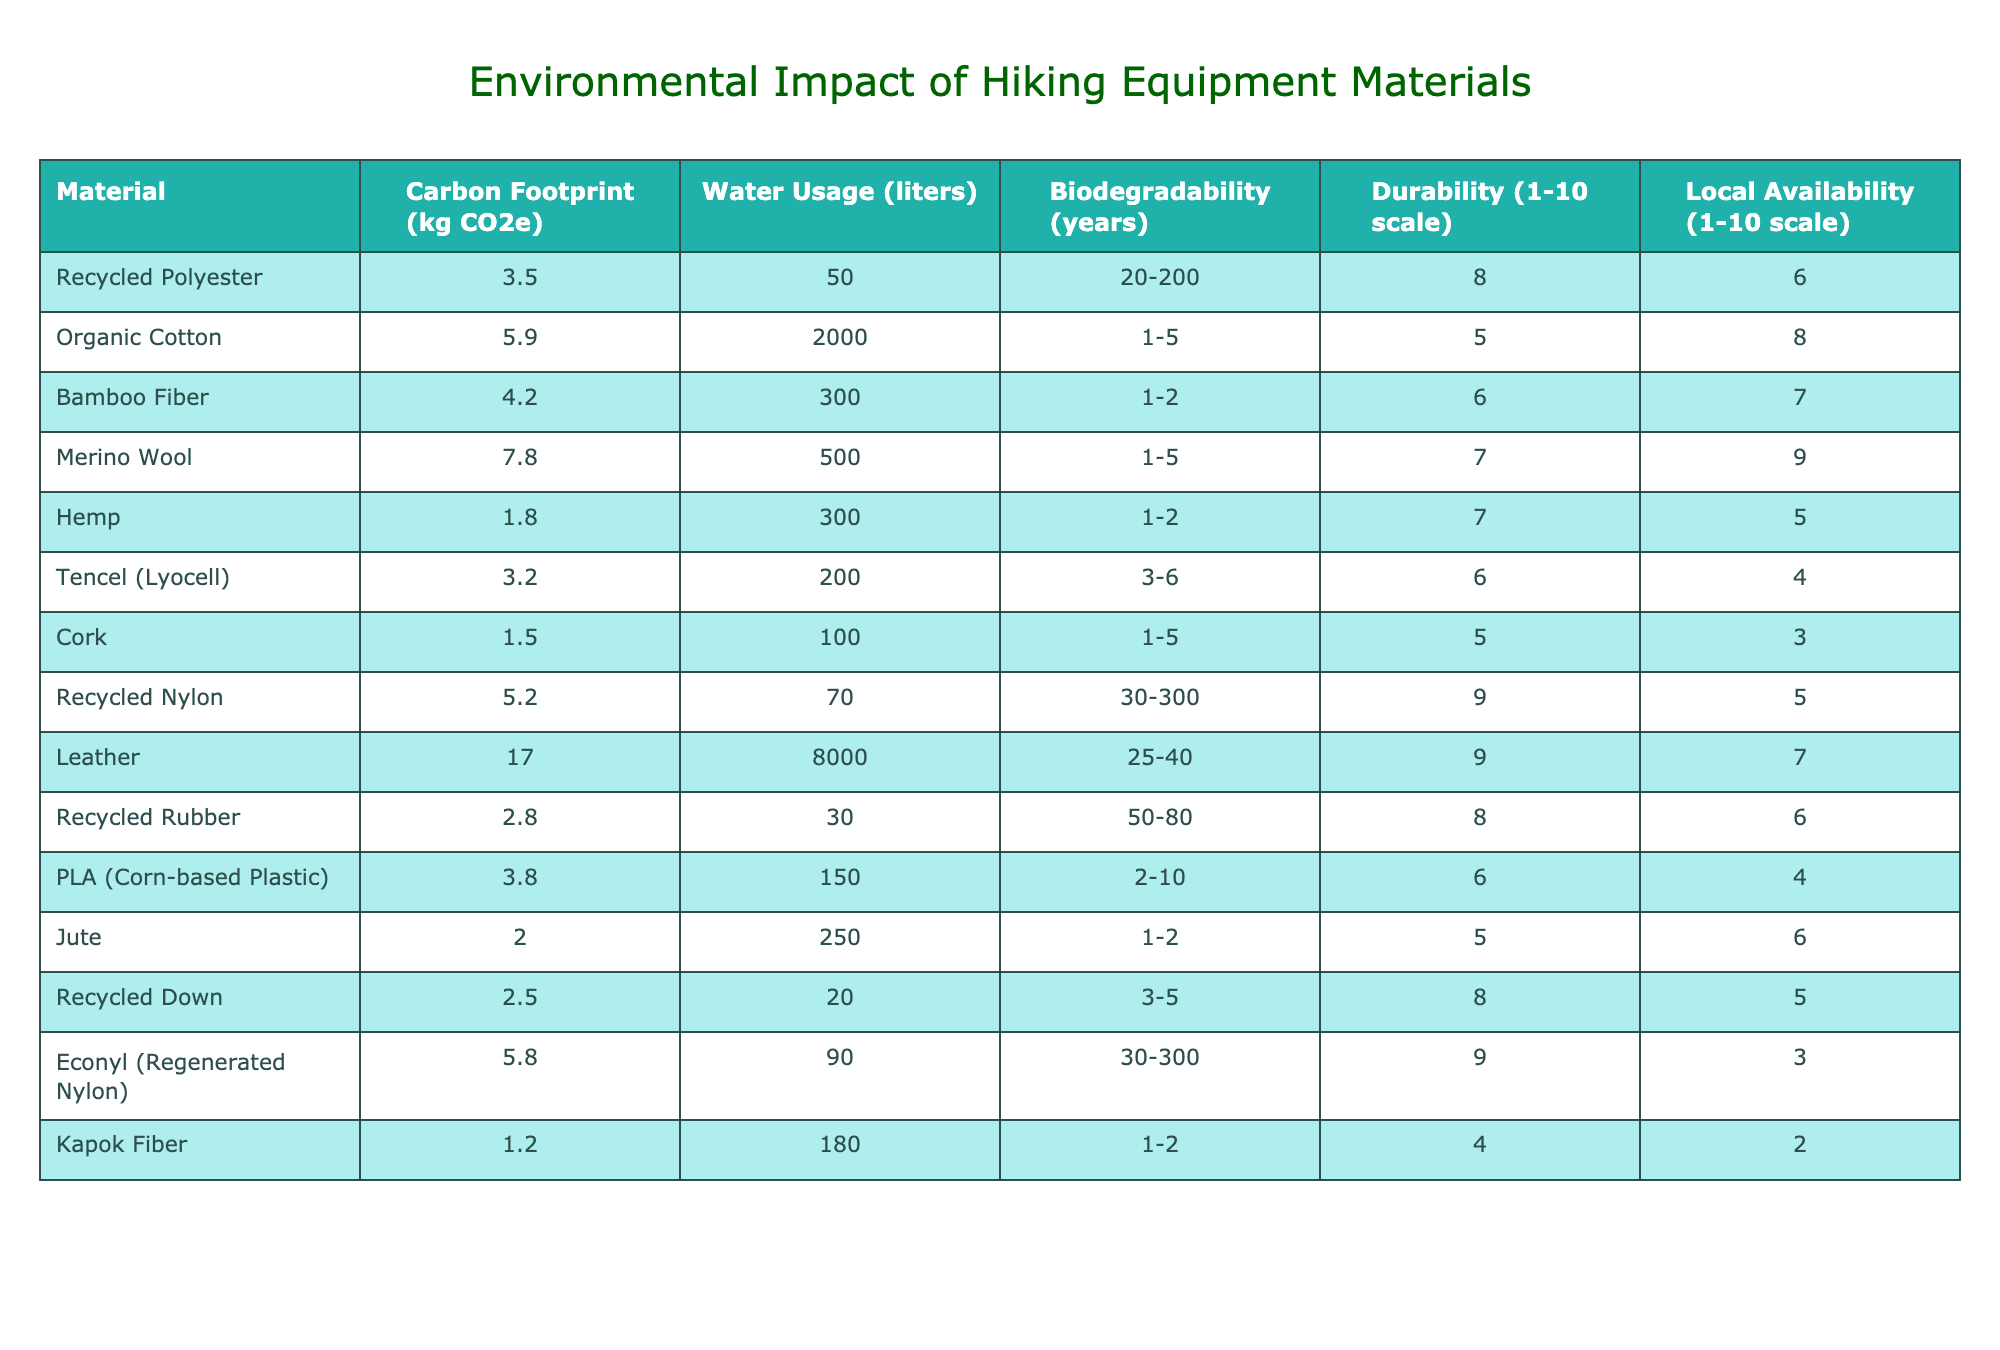What material has the lowest carbon footprint? The carbon footprints of the materials are listed in the second column. When comparing the values, Cork has the lowest footprint at 1.5 kg CO2e.
Answer: 1.5 kg CO2e How many liters of water does Organic Cotton use compared to Hemp? The water usage for Organic Cotton is 2000 liters and for Hemp, it is 300 liters. The difference is 2000 - 300 = 1700 liters more for Organic Cotton.
Answer: 1700 liters Is Merino Wool biodegradable in 30 years? Merino Wool has a biodegradability range of 1-5 years, which means it cannot be biodegradable in 30 years.
Answer: No What is the average carbon footprint of the biodegradable materials? The biodegradable materials are Organic Cotton, Bamboo Fiber, Hemp, Merino Wool, Jute, and Kapok Fiber. Their carbon footprints are 5.9, 4.2, 1.8, 7.8, 2.0, and 1.2 kg CO2e respectively. Summing these gives 23.9 kg CO2e, dividing by 6 gives the average of approximately 3.98 kg CO2e.
Answer: 3.98 kg CO2e Which material has the highest durability rating? The durability ratings are provided on a scale of 1-10, with the highest being Leather and Recycled Nylon, both receiving a score of 9.
Answer: Leather and Recycled Nylon What is the total water usage for Recycled Nylon and Recycled Down? The water usage for Recycled Nylon is 70 liters and for Recycled Down, it is 20 liters. Adding these values gives a total of 70 + 20 = 90 liters.
Answer: 90 liters Does Tencel have a higher local availability rating than Jute? Tencel has a local availability rating of 4, whereas Jute has a rating of 6. Since 6 is greater than 4, Tencel does not have a higher rating.
Answer: No What is the difference in durability between Recycled Polyester and Bamboo Fiber? Recycled Polyester has a durability rating of 8, while Bamboo Fiber has a rating of 6. The difference is 8 - 6 = 2 in durability.
Answer: 2 